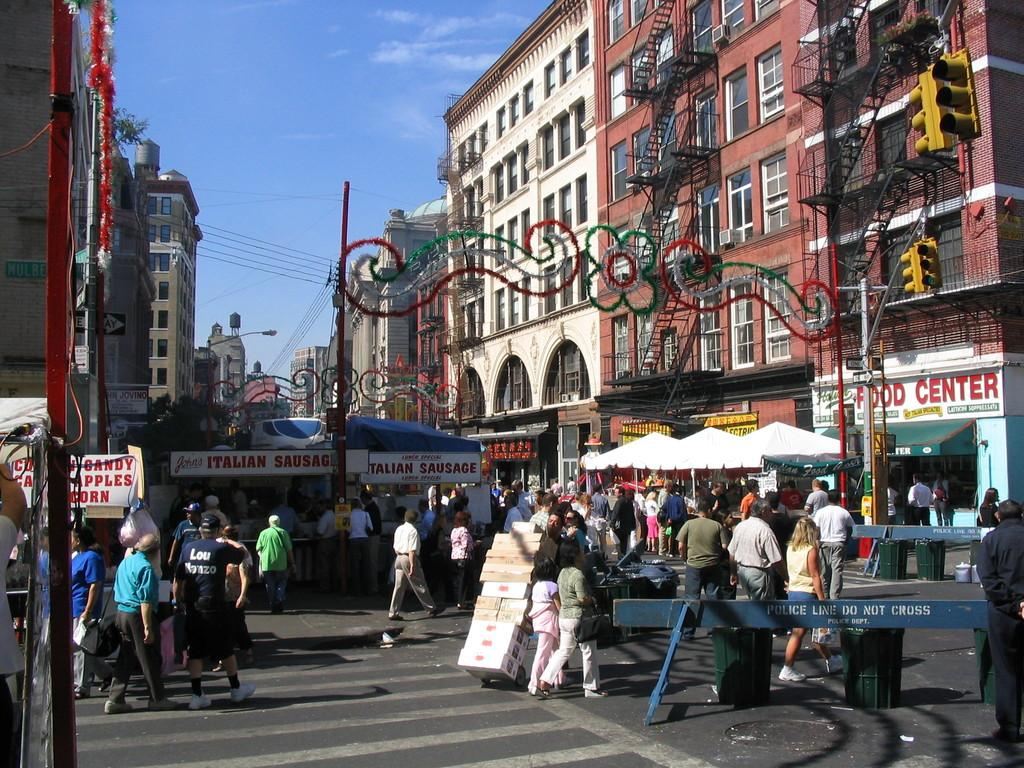What type of structures can be seen in the image? There are buildings in the image. What else can be found in the image besides buildings? There are stalls in the image. What are the people in the image doing? Some people are standing in front of the stalls, while others are walking on the road. What can be seen in the background of the image? There is a sky visible in the background of the image. What type of locket is hanging from the nerve of the person in the image? There is no person with a nerve or locket present in the image. 